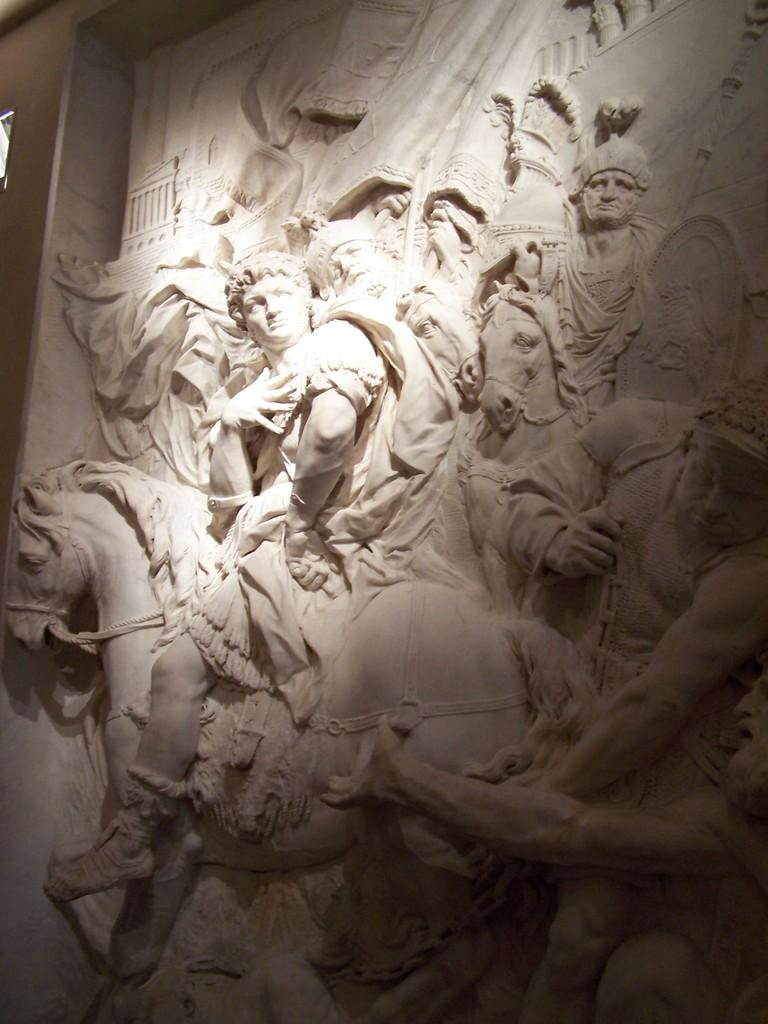What is depicted on the wall in the image? There are sculptures on the wall in the image. What rate do the ducks swim in the image? There are no ducks present in the image, so it is not possible to determine their swimming rate. 